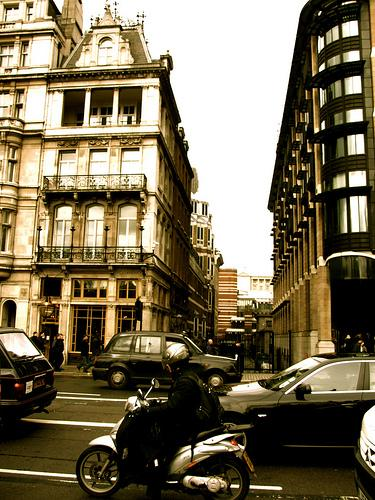In an eloquent manner, describe an architectural feature found in the image. Tall, majestic buildings stretch gracefully across the skyline, creating an interesting juxtaposition with the bustling street activity. Find the object in the bottom part of the image just above the motorcycle and describe it. It is a black protective helmet positioned just above the motorcycle. Briefly describe the scene captured in the image in a poetic style. Amidst the urban sprawl, man and machine glide gracefully, while towering buildings bear witness to their fleeting dance. Identify an accessory worn by the person riding the scooter. The person riding the scooter is wearing a helmet. Can you provide a summary of this image? The image has a silver motorcycle with a person riding it, a black car, a helmet, and tall buildings across the street. What can you see painted on the street in the image? There are white lines painted on the street. What color is the car traveling through traffic in this image? The car traveling through traffic is black. List three types of vehicles found in the image. Motorcycle, car, and a scooter. What is the color of the motorcycle in the image? The motorcycle in the image is silver. 